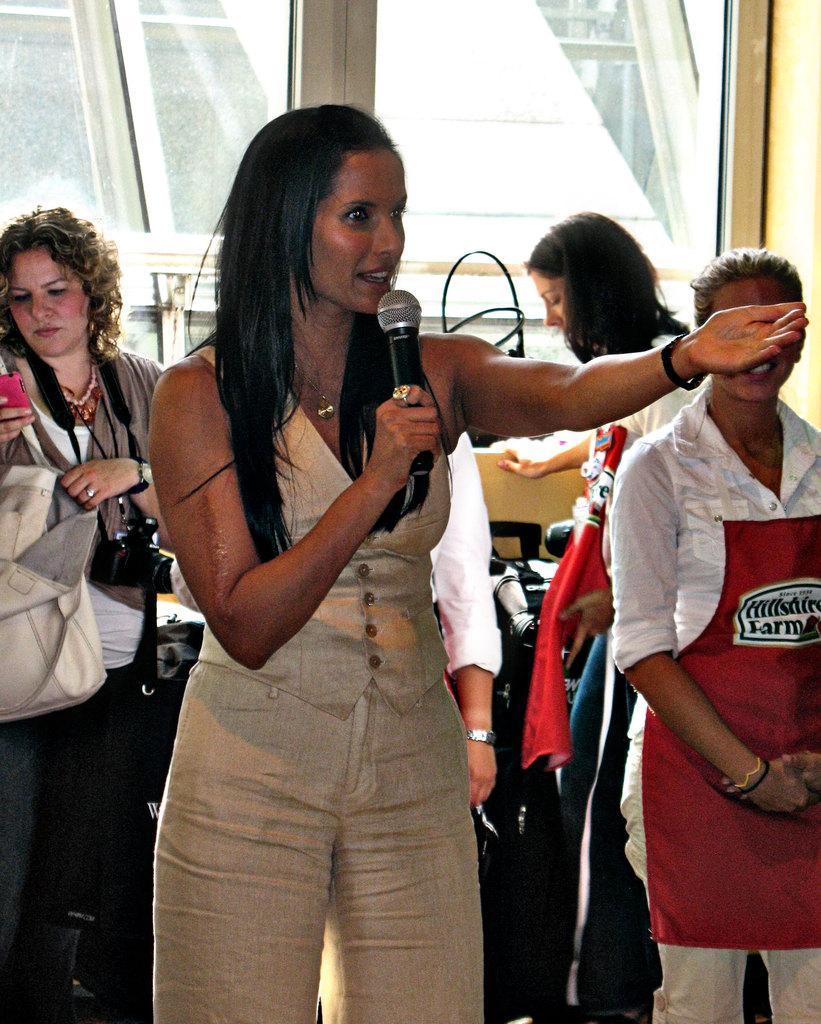Can you describe this image briefly? This picture shows a woman holding a mic in her hand and talking. In the background there are some people standing. We can observe a window here. 